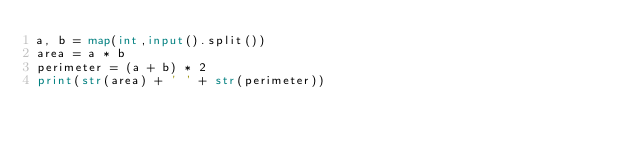Convert code to text. <code><loc_0><loc_0><loc_500><loc_500><_Python_>a, b = map(int,input().split())
area = a * b
perimeter = (a + b) * 2
print(str(area) + ' ' + str(perimeter))
</code> 